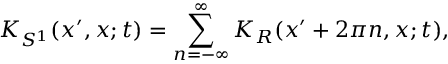Convert formula to latex. <formula><loc_0><loc_0><loc_500><loc_500>K _ { S ^ { 1 } } ( x ^ { \prime } , x ; t ) = \sum _ { n = - \infty } ^ { \infty } K _ { R } ( x ^ { \prime } + 2 \pi n , x ; t ) ,</formula> 